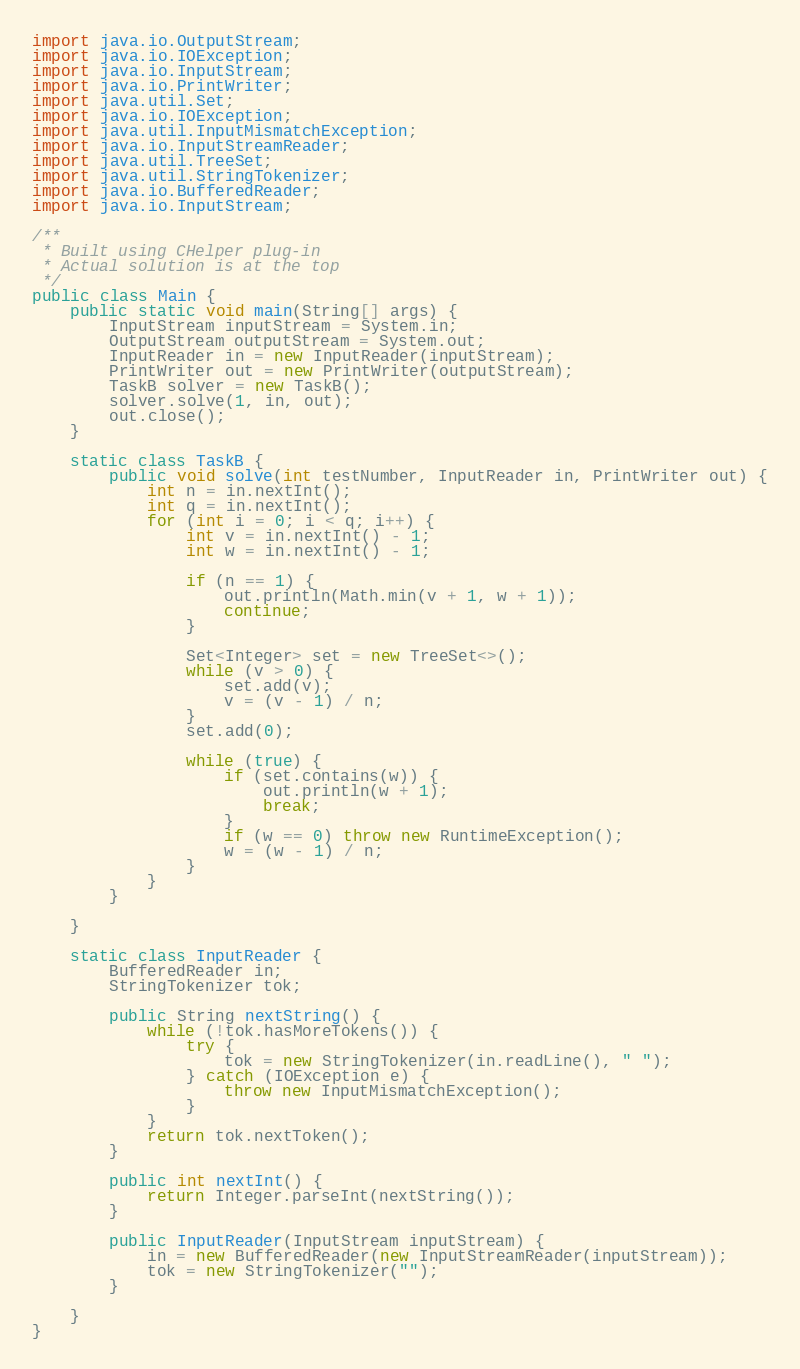<code> <loc_0><loc_0><loc_500><loc_500><_Java_>import java.io.OutputStream;
import java.io.IOException;
import java.io.InputStream;
import java.io.PrintWriter;
import java.util.Set;
import java.io.IOException;
import java.util.InputMismatchException;
import java.io.InputStreamReader;
import java.util.TreeSet;
import java.util.StringTokenizer;
import java.io.BufferedReader;
import java.io.InputStream;

/**
 * Built using CHelper plug-in
 * Actual solution is at the top
 */
public class Main {
    public static void main(String[] args) {
        InputStream inputStream = System.in;
        OutputStream outputStream = System.out;
        InputReader in = new InputReader(inputStream);
        PrintWriter out = new PrintWriter(outputStream);
        TaskB solver = new TaskB();
        solver.solve(1, in, out);
        out.close();
    }

    static class TaskB {
        public void solve(int testNumber, InputReader in, PrintWriter out) {
            int n = in.nextInt();
            int q = in.nextInt();
            for (int i = 0; i < q; i++) {
                int v = in.nextInt() - 1;
                int w = in.nextInt() - 1;

                if (n == 1) {
                    out.println(Math.min(v + 1, w + 1));
                    continue;
                }

                Set<Integer> set = new TreeSet<>();
                while (v > 0) {
                    set.add(v);
                    v = (v - 1) / n;
                }
                set.add(0);

                while (true) {
                    if (set.contains(w)) {
                        out.println(w + 1);
                        break;
                    }
                    if (w == 0) throw new RuntimeException();
                    w = (w - 1) / n;
                }
            }
        }

    }

    static class InputReader {
        BufferedReader in;
        StringTokenizer tok;

        public String nextString() {
            while (!tok.hasMoreTokens()) {
                try {
                    tok = new StringTokenizer(in.readLine(), " ");
                } catch (IOException e) {
                    throw new InputMismatchException();
                }
            }
            return tok.nextToken();
        }

        public int nextInt() {
            return Integer.parseInt(nextString());
        }

        public InputReader(InputStream inputStream) {
            in = new BufferedReader(new InputStreamReader(inputStream));
            tok = new StringTokenizer("");
        }

    }
}

</code> 